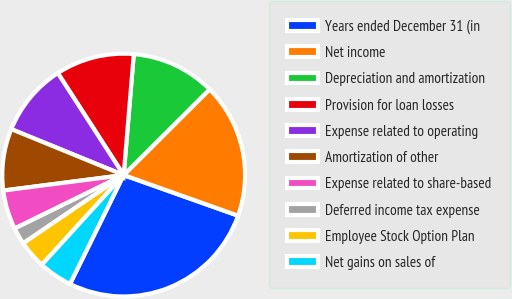Convert chart to OTSL. <chart><loc_0><loc_0><loc_500><loc_500><pie_chart><fcel>Years ended December 31 (in<fcel>Net income<fcel>Depreciation and amortization<fcel>Provision for loan losses<fcel>Expense related to operating<fcel>Amortization of other<fcel>Expense related to share-based<fcel>Deferred income tax expense<fcel>Employee Stock Option Plan<fcel>Net gains on sales of<nl><fcel>26.86%<fcel>17.91%<fcel>11.19%<fcel>10.45%<fcel>9.7%<fcel>8.21%<fcel>5.22%<fcel>2.24%<fcel>3.73%<fcel>4.48%<nl></chart> 